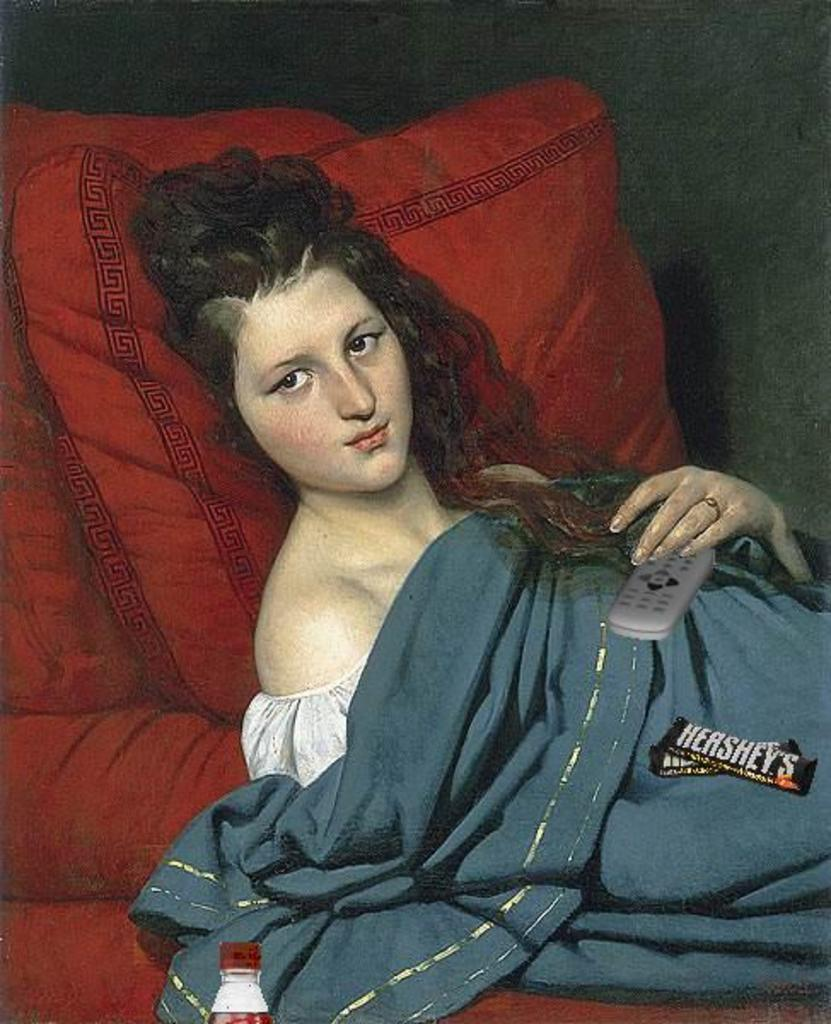What is depicted in the painting in the image? There is a painting of a woman in the image. What is the woman holding in the painting? The woman is holding a remote in the painting. What type of furniture is present in the image? There is a red color couch with a pillow in the image. What other objects can be seen in the image? There is a blanket and a bottle in the image. How many bricks are visible in the image? There are no bricks present in the image. What type of support does the woman in the painting need? The woman in the painting does not need any support, as she is a subject in a painting and not a real person. 